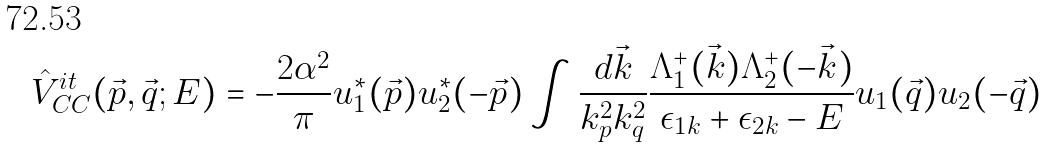<formula> <loc_0><loc_0><loc_500><loc_500>\hat { V } _ { C C } ^ { i t } ( \vec { p } , \vec { q } ; E ) = - \frac { 2 \alpha ^ { 2 } } { \pi } u _ { 1 } ^ { * } ( \vec { p } ) u _ { 2 } ^ { * } ( - \vec { p } ) \int \frac { d \vec { k } } { k _ { p } ^ { 2 } k _ { q } ^ { 2 } } \frac { \Lambda ^ { + } _ { 1 } ( \vec { k } ) \Lambda ^ { + } _ { 2 } ( - \vec { k } ) } { \epsilon _ { 1 k } + \epsilon _ { 2 k } - E } u _ { 1 } ( \vec { q } ) u _ { 2 } ( - \vec { q } )</formula> 